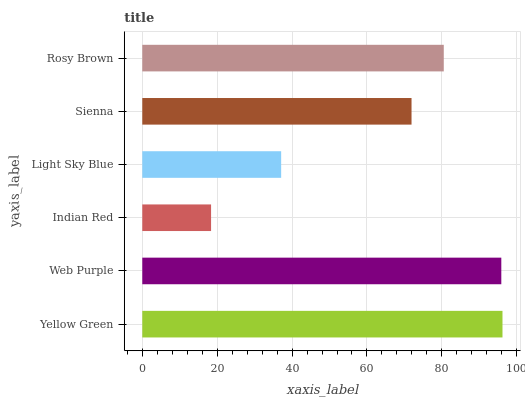Is Indian Red the minimum?
Answer yes or no. Yes. Is Yellow Green the maximum?
Answer yes or no. Yes. Is Web Purple the minimum?
Answer yes or no. No. Is Web Purple the maximum?
Answer yes or no. No. Is Yellow Green greater than Web Purple?
Answer yes or no. Yes. Is Web Purple less than Yellow Green?
Answer yes or no. Yes. Is Web Purple greater than Yellow Green?
Answer yes or no. No. Is Yellow Green less than Web Purple?
Answer yes or no. No. Is Rosy Brown the high median?
Answer yes or no. Yes. Is Sienna the low median?
Answer yes or no. Yes. Is Yellow Green the high median?
Answer yes or no. No. Is Yellow Green the low median?
Answer yes or no. No. 